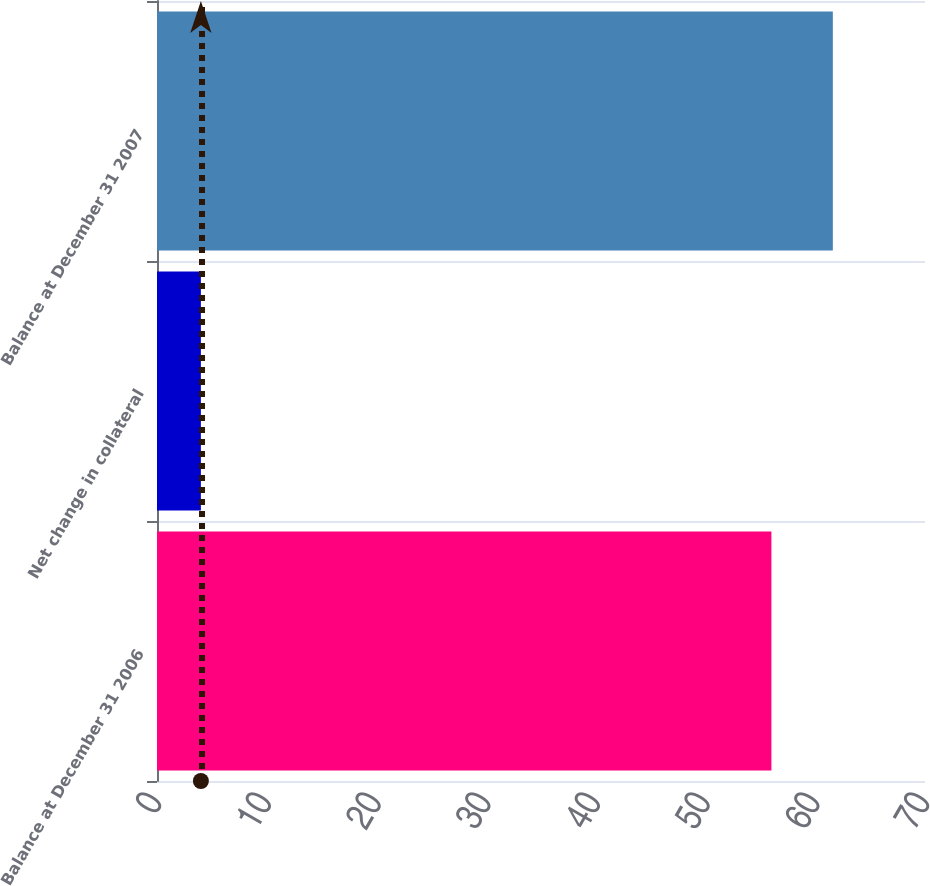Convert chart. <chart><loc_0><loc_0><loc_500><loc_500><bar_chart><fcel>Balance at December 31 2006<fcel>Net change in collateral<fcel>Balance at December 31 2007<nl><fcel>56<fcel>4<fcel>61.6<nl></chart> 